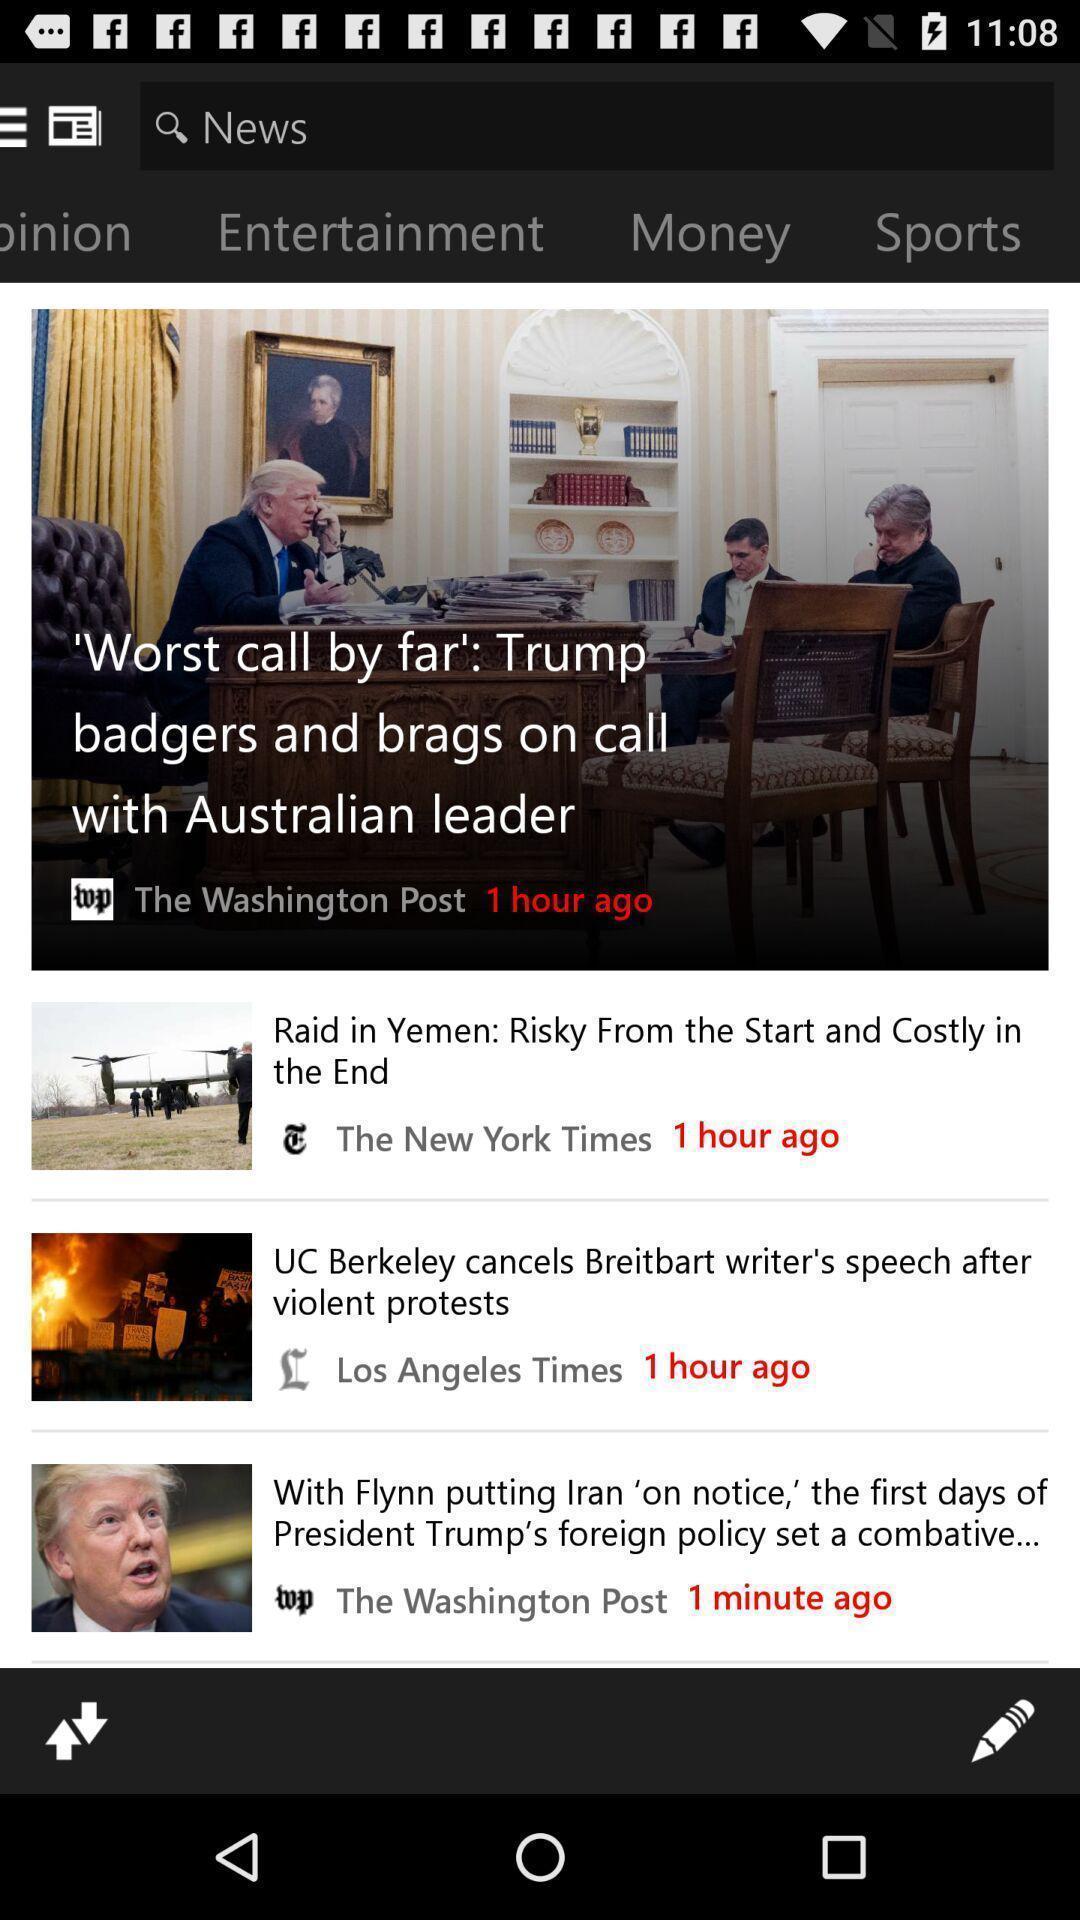Tell me about the visual elements in this screen capture. Screen showing the thumbnails of latest news. 